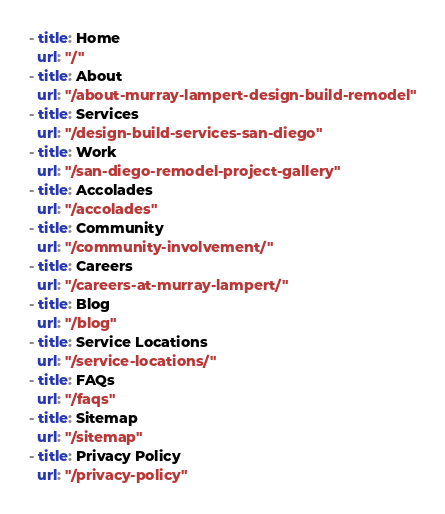Convert code to text. <code><loc_0><loc_0><loc_500><loc_500><_YAML_>- title: Home
  url: "/"
- title: About
  url: "/about-murray-lampert-design-build-remodel"
- title: Services
  url: "/design-build-services-san-diego"
- title: Work
  url: "/san-diego-remodel-project-gallery"
- title: Accolades
  url: "/accolades"
- title: Community
  url: "/community-involvement/"
- title: Careers
  url: "/careers-at-murray-lampert/"
- title: Blog
  url: "/blog"
- title: Service Locations
  url: "/service-locations/"
- title: FAQs
  url: "/faqs"
- title: Sitemap
  url: "/sitemap"
- title: Privacy Policy
  url: "/privacy-policy"
</code> 